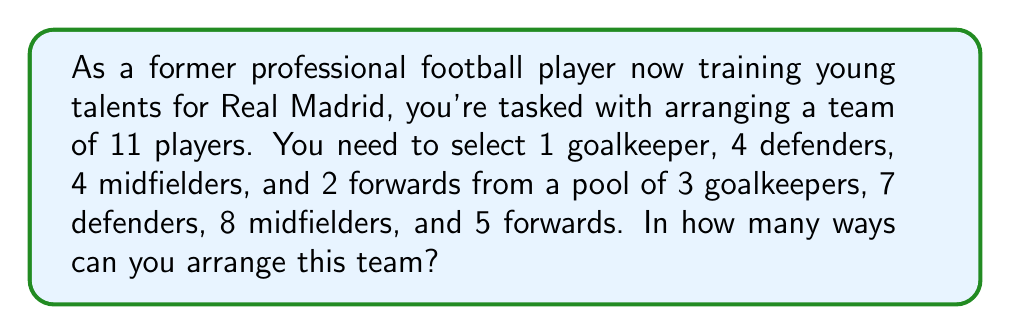Can you answer this question? Let's break this down step by step:

1) First, we need to select players for each position:
   - 1 goalkeeper from 3: $\binom{3}{1}$ ways
   - 4 defenders from 7: $\binom{7}{4}$ ways
   - 4 midfielders from 8: $\binom{8}{4}$ ways
   - 2 forwards from 5: $\binom{5}{2}$ ways

2) The number of ways to select players for each position is:
   $$\binom{3}{1} \cdot \binom{7}{4} \cdot \binom{8}{4} \cdot \binom{5}{2}$$

3) Let's calculate each combination:
   $$\binom{3}{1} = 3$$
   $$\binom{7}{4} = \frac{7!}{4!(7-4)!} = \frac{7!}{4!3!} = 35$$
   $$\binom{8}{4} = \frac{8!}{4!(8-4)!} = \frac{8!}{4!4!} = 70$$
   $$\binom{5}{2} = \frac{5!}{2!(5-2)!} = \frac{5!}{2!3!} = 10$$

4) Multiply these results:
   $$3 \cdot 35 \cdot 70 \cdot 10 = 73,500$$

Therefore, there are 73,500 ways to select the players for each position.
Answer: 73,500 ways 